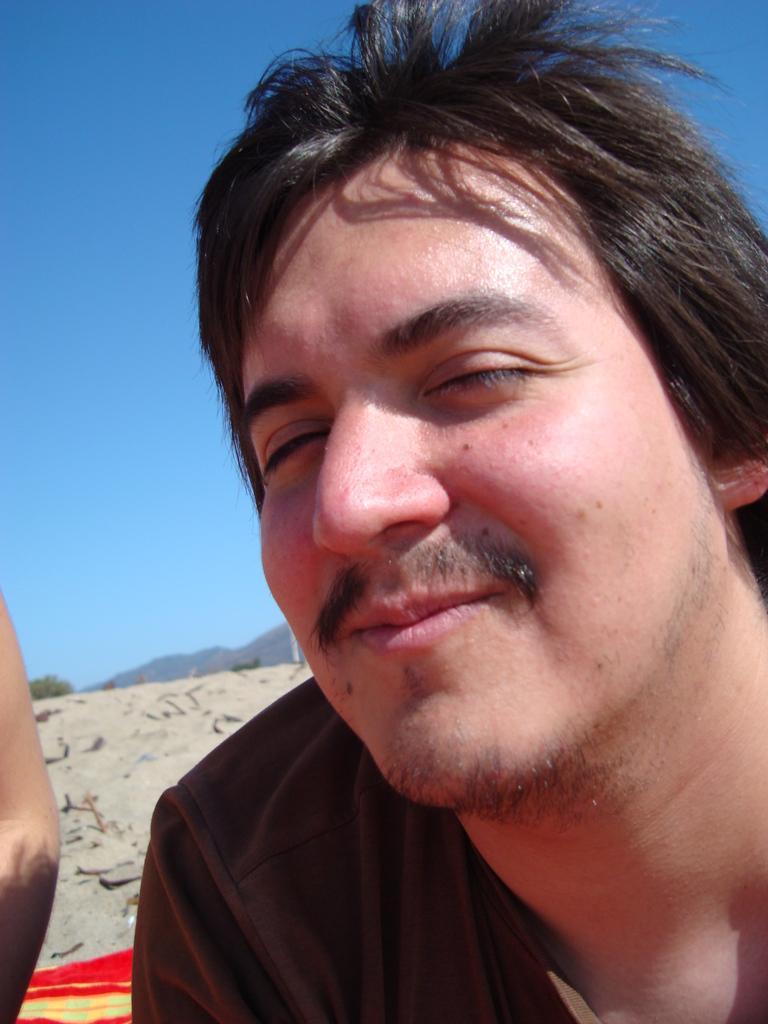Can you describe this image briefly? There is a person in a t-shirt smiling. In the background, there is sand surface, there is a tree, mountain and blue sky. 